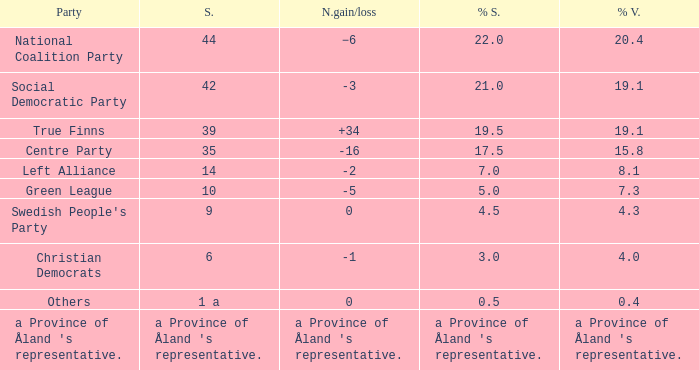Would you be able to parse every entry in this table? {'header': ['Party', 'S.', 'N.gain/loss', '% S.', '% V.'], 'rows': [['National Coalition Party', '44', '−6', '22.0', '20.4'], ['Social Democratic Party', '42', '-3', '21.0', '19.1'], ['True Finns', '39', '+34', '19.5', '19.1'], ['Centre Party', '35', '-16', '17.5', '15.8'], ['Left Alliance', '14', '-2', '7.0', '8.1'], ['Green League', '10', '-5', '5.0', '7.3'], ["Swedish People's Party", '9', '0', '4.5', '4.3'], ['Christian Democrats', '6', '-1', '3.0', '4.0'], ['Others', '1 a', '0', '0.5', '0.4'], ["a Province of Åland 's representative.", "a Province of Åland 's representative.", "a Province of Åland 's representative.", "a Province of Åland 's representative.", "a Province of Åland 's representative."]]} When there was a net gain/loss of +34, what was the percentage of seats that party held? 19.5. 